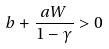Convert formula to latex. <formula><loc_0><loc_0><loc_500><loc_500>b + \frac { a W } { 1 - \gamma } > 0</formula> 